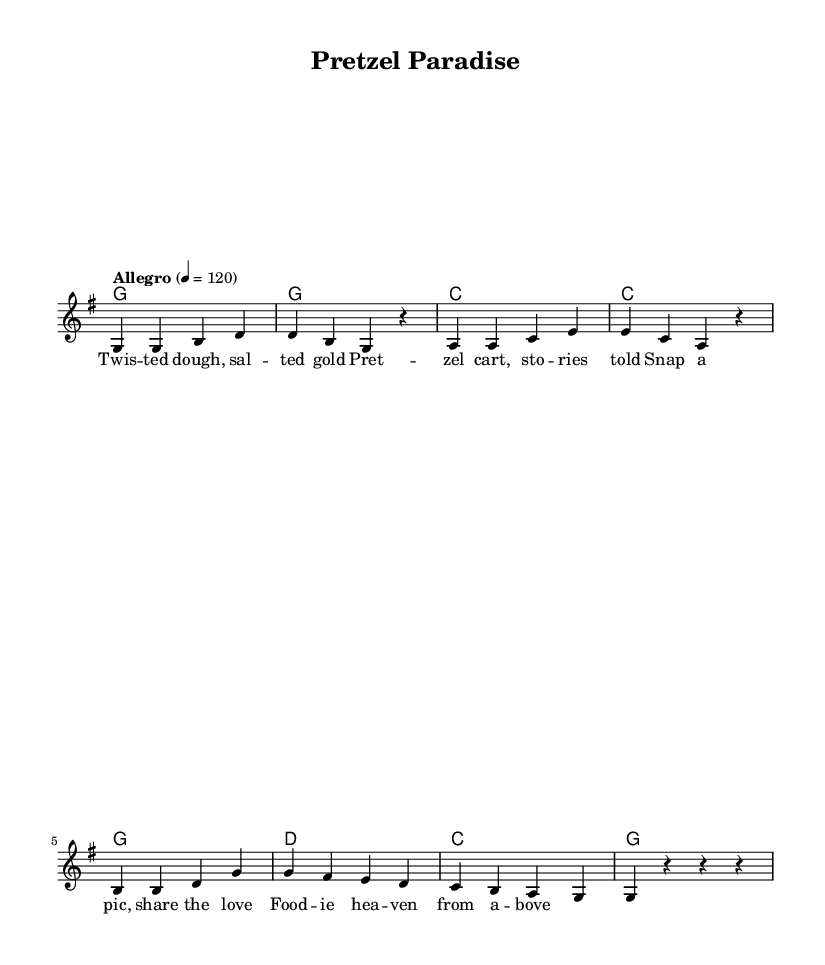What is the key signature of this music? The key signature is G major, indicated by one sharp (F#).
Answer: G major What is the time signature of this music? The time signature is 4/4, meaning there are four beats per measure.
Answer: 4/4 What is the tempo marking of this piece? The tempo marking is "Allegro," which indicates a fast, lively tempo, specifically set at 120 beats per minute.
Answer: Allegro How many measures are in the melody? The melody consists of 8 measures, as counted from the provided notes.
Answer: 8 In which part of the song are the lyrics presented? The lyrics are sung in the "lead" voice, which is the melody voice in the score.
Answer: Lead What is the first note of the melody? The first note of the melody is G, as indicated at the beginning of the melody line.
Answer: G Which musical form does the song follow? The song follows a verse-chorus structure defined by the repeating lyrical themes and melody.
Answer: Verse-chorus 